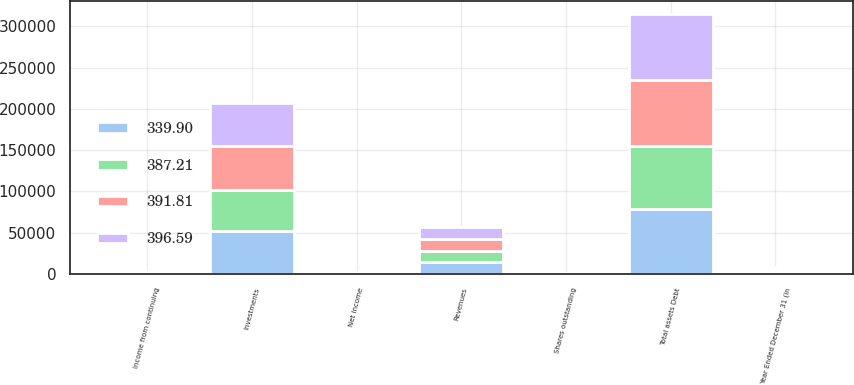Convert chart. <chart><loc_0><loc_0><loc_500><loc_500><stacked_bar_chart><ecel><fcel>Year Ended December 31 (In<fcel>Revenues<fcel>Income from continuing<fcel>Net income<fcel>Investments<fcel>Total assets Debt<fcel>Shares outstanding<nl><fcel>387.21<fcel>2015<fcel>13415<fcel>260<fcel>260<fcel>49400<fcel>76029<fcel>339.9<nl><fcel>339.9<fcel>2014<fcel>14325<fcel>962<fcel>591<fcel>52032<fcel>78367<fcel>372.93<nl><fcel>396.59<fcel>2013<fcel>14613<fcel>1149<fcel>595<fcel>52945<fcel>79939<fcel>387.21<nl><fcel>391.81<fcel>2012<fcel>14072<fcel>968<fcel>568<fcel>53040<fcel>80021<fcel>391.81<nl></chart> 